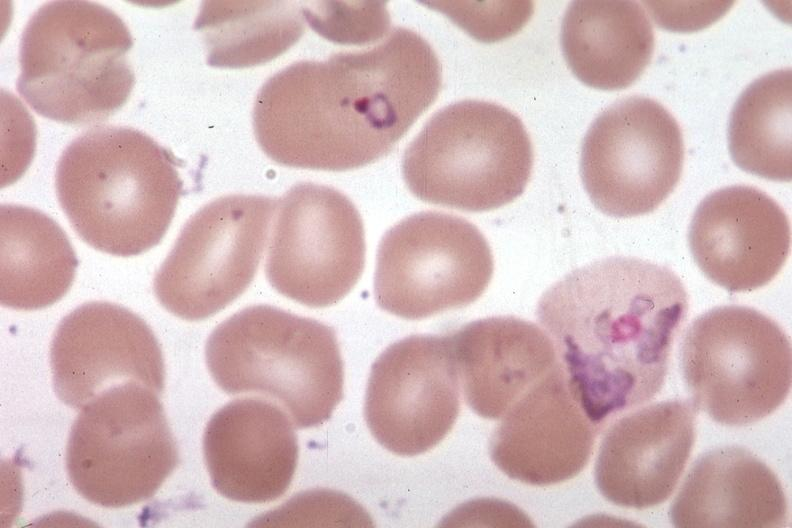what is present?
Answer the question using a single word or phrase. Malaria plasmodium vivax 